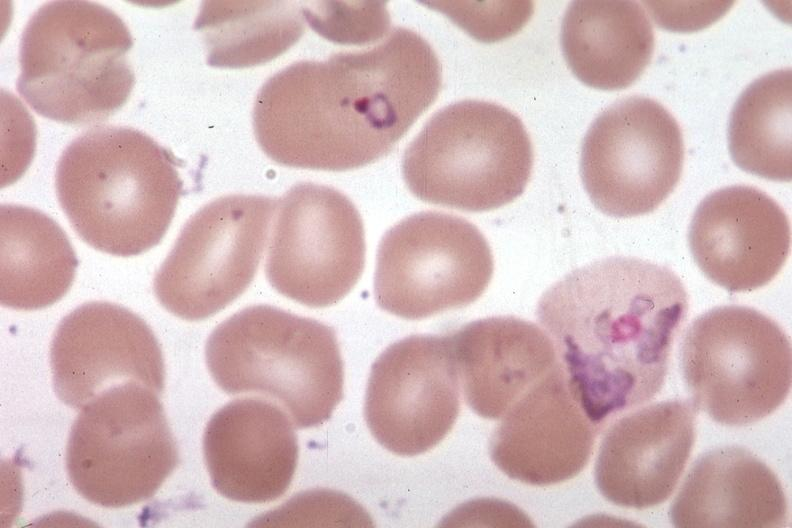what is present?
Answer the question using a single word or phrase. Malaria plasmodium vivax 